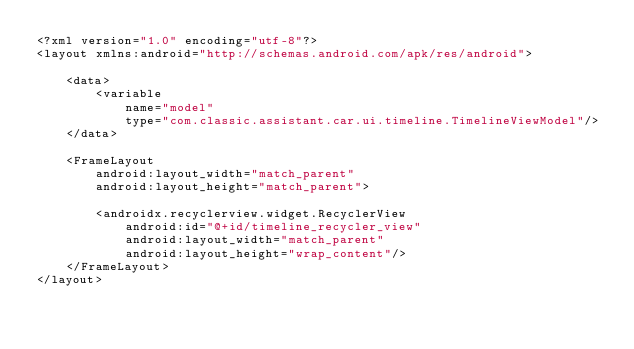<code> <loc_0><loc_0><loc_500><loc_500><_XML_><?xml version="1.0" encoding="utf-8"?>
<layout xmlns:android="http://schemas.android.com/apk/res/android">

    <data>
        <variable
            name="model"
            type="com.classic.assistant.car.ui.timeline.TimelineViewModel"/>
    </data>

    <FrameLayout
        android:layout_width="match_parent"
        android:layout_height="match_parent">

        <androidx.recyclerview.widget.RecyclerView
            android:id="@+id/timeline_recycler_view"
            android:layout_width="match_parent"
            android:layout_height="wrap_content"/>
    </FrameLayout>
</layout></code> 